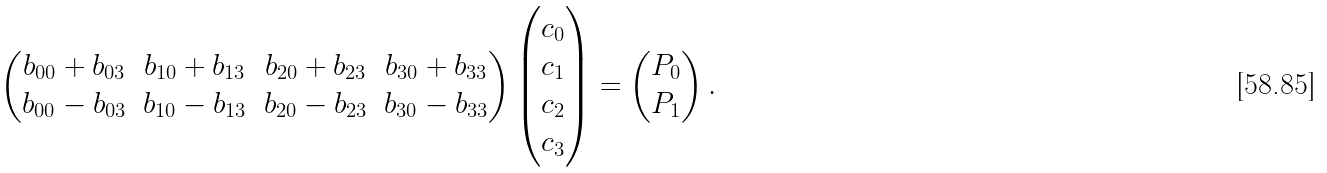Convert formula to latex. <formula><loc_0><loc_0><loc_500><loc_500>\begin{pmatrix} b _ { 0 0 } + b _ { 0 3 } & b _ { 1 0 } + b _ { 1 3 } & b _ { 2 0 } + b _ { 2 3 } & b _ { 3 0 } + b _ { 3 3 } \\ b _ { 0 0 } - b _ { 0 3 } & b _ { 1 0 } - b _ { 1 3 } & b _ { 2 0 } - b _ { 2 3 } & b _ { 3 0 } - b _ { 3 3 } \end{pmatrix} \begin{pmatrix} c _ { 0 } \\ c _ { 1 } \\ c _ { 2 } \\ c _ { 3 } \end{pmatrix} = \begin{pmatrix} P _ { 0 } \\ P _ { 1 } \end{pmatrix} .</formula> 